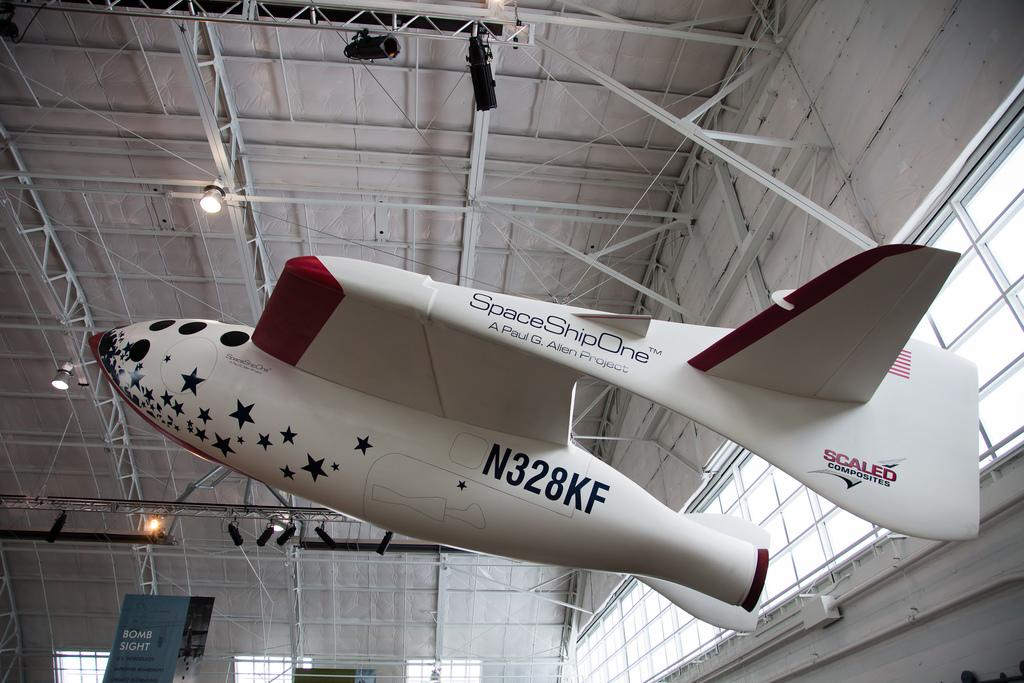<image>
Describe the image concisely. A plane labelled Space Ship One is arranged for viewing in a building. 